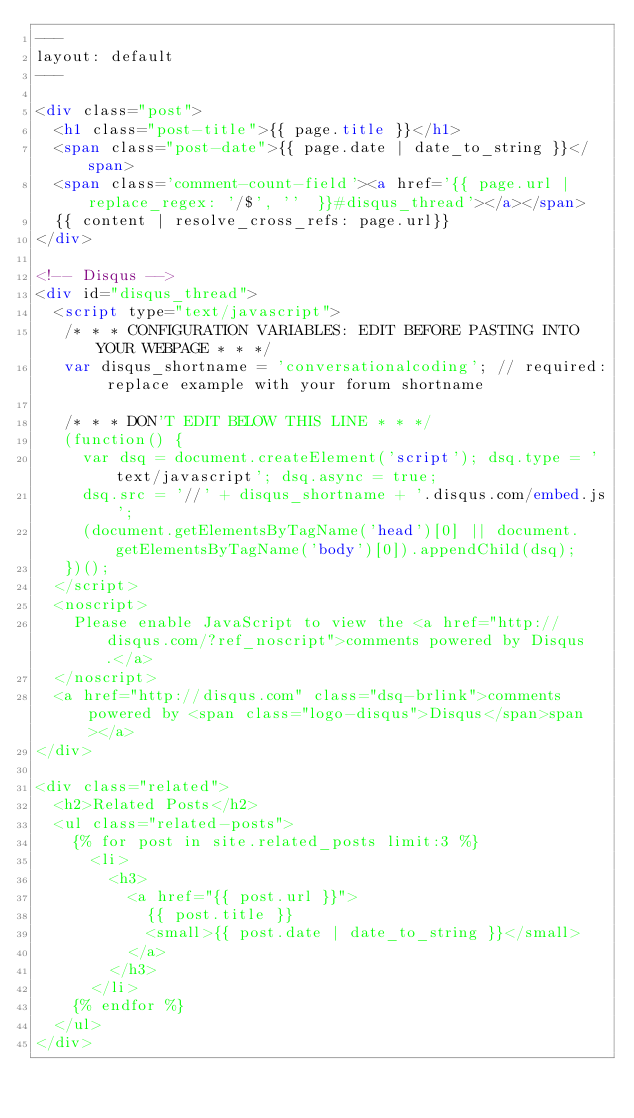<code> <loc_0><loc_0><loc_500><loc_500><_HTML_>---
layout: default
---

<div class="post">
  <h1 class="post-title">{{ page.title }}</h1>
  <span class="post-date">{{ page.date | date_to_string }}</span>
  <span class='comment-count-field'><a href='{{ page.url | replace_regex: '/$', ''  }}#disqus_thread'></a></span>
  {{ content | resolve_cross_refs: page.url}}
</div>

<!-- Disqus -->
<div id="disqus_thread">
  <script type="text/javascript">
   /* * * CONFIGURATION VARIABLES: EDIT BEFORE PASTING INTO YOUR WEBPAGE * * */
   var disqus_shortname = 'conversationalcoding'; // required: replace example with your forum shortname
   
   /* * * DON'T EDIT BELOW THIS LINE * * */
   (function() {
     var dsq = document.createElement('script'); dsq.type = 'text/javascript'; dsq.async = true;
     dsq.src = '//' + disqus_shortname + '.disqus.com/embed.js';
     (document.getElementsByTagName('head')[0] || document.getElementsByTagName('body')[0]).appendChild(dsq);
   })();
  </script>
  <noscript>
    Please enable JavaScript to view the <a href="http://disqus.com/?ref_noscript">comments powered by Disqus.</a>
  </noscript>
  <a href="http://disqus.com" class="dsq-brlink">comments powered by <span class="logo-disqus">Disqus</span>span></a>
</div>

<div class="related">
  <h2>Related Posts</h2>
  <ul class="related-posts">
    {% for post in site.related_posts limit:3 %}
      <li>
        <h3>
          <a href="{{ post.url }}">
            {{ post.title }}
            <small>{{ post.date | date_to_string }}</small>
          </a>
        </h3>
      </li>
    {% endfor %}
  </ul>
</div>
</code> 